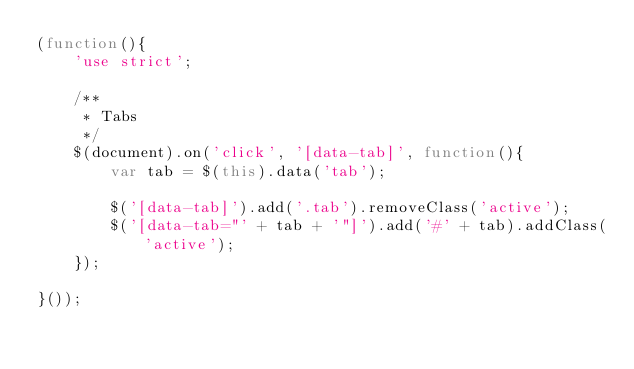<code> <loc_0><loc_0><loc_500><loc_500><_JavaScript_>(function(){
	'use strict';

	/**
	 * Tabs
	 */
	$(document).on('click', '[data-tab]', function(){
		var tab = $(this).data('tab');
		
		$('[data-tab]').add('.tab').removeClass('active');
		$('[data-tab="' + tab + '"]').add('#' + tab).addClass('active');
	});

}());</code> 